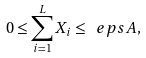<formula> <loc_0><loc_0><loc_500><loc_500>0 \leq \sum _ { i = 1 } ^ { L } X _ { i } \leq \ e p s A ,</formula> 